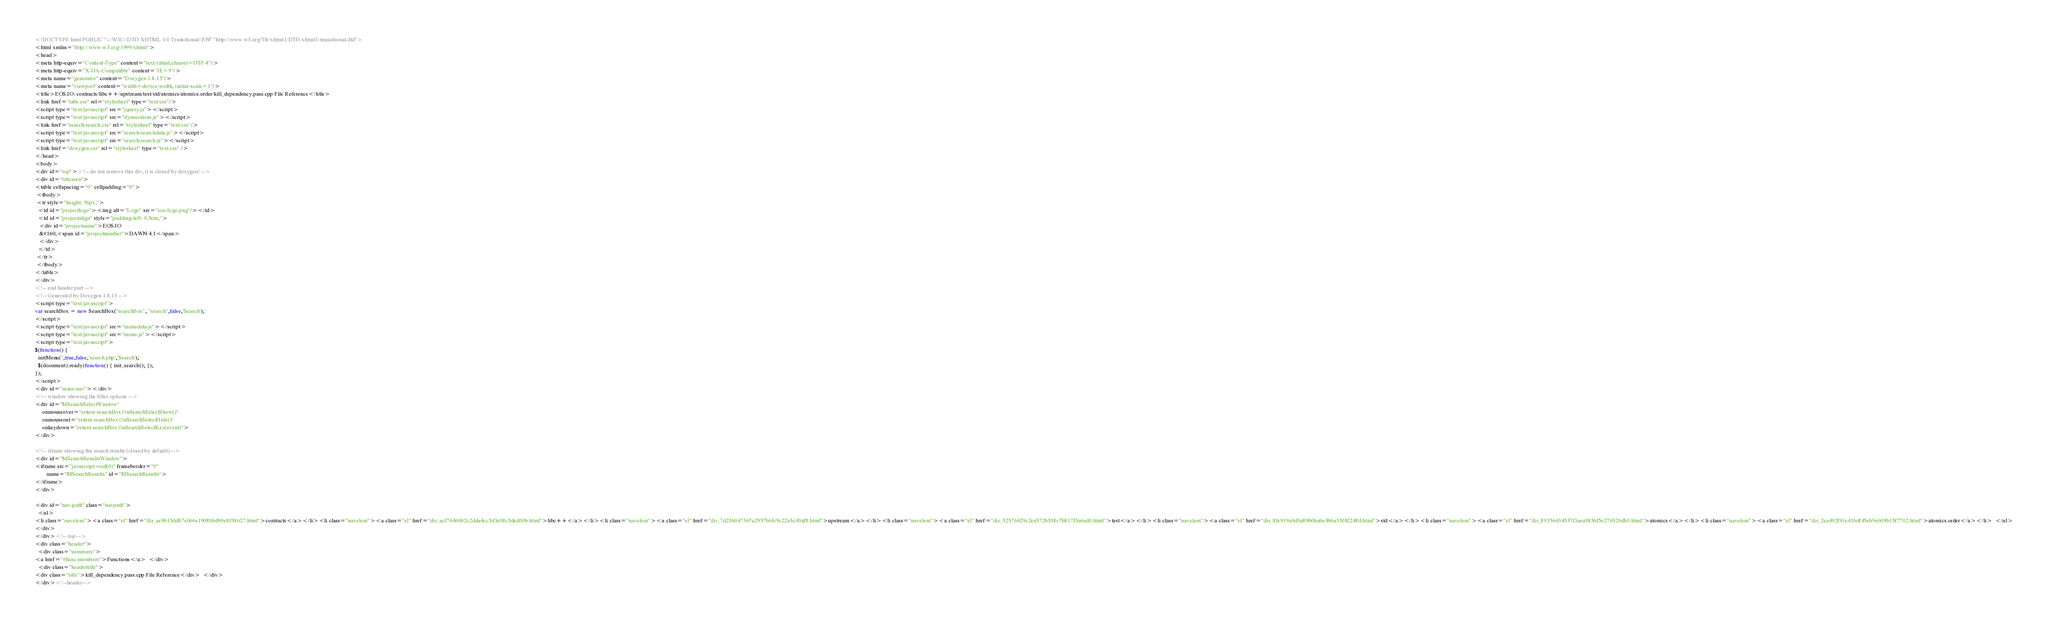Convert code to text. <code><loc_0><loc_0><loc_500><loc_500><_HTML_><!DOCTYPE html PUBLIC "-//W3C//DTD XHTML 1.0 Transitional//EN" "http://www.w3.org/TR/xhtml1/DTD/xhtml1-transitional.dtd">
<html xmlns="http://www.w3.org/1999/xhtml">
<head>
<meta http-equiv="Content-Type" content="text/xhtml;charset=UTF-8"/>
<meta http-equiv="X-UA-Compatible" content="IE=9"/>
<meta name="generator" content="Doxygen 1.8.13"/>
<meta name="viewport" content="width=device-width, initial-scale=1"/>
<title>EOS.IO: contracts/libc++/upstream/test/std/atomics/atomics.order/kill_dependency.pass.cpp File Reference</title>
<link href="tabs.css" rel="stylesheet" type="text/css"/>
<script type="text/javascript" src="jquery.js"></script>
<script type="text/javascript" src="dynsections.js"></script>
<link href="search/search.css" rel="stylesheet" type="text/css"/>
<script type="text/javascript" src="search/searchdata.js"></script>
<script type="text/javascript" src="search/search.js"></script>
<link href="doxygen.css" rel="stylesheet" type="text/css" />
</head>
<body>
<div id="top"><!-- do not remove this div, it is closed by doxygen! -->
<div id="titlearea">
<table cellspacing="0" cellpadding="0">
 <tbody>
 <tr style="height: 56px;">
  <td id="projectlogo"><img alt="Logo" src="eos-logo.png"/></td>
  <td id="projectalign" style="padding-left: 0.5em;">
   <div id="projectname">EOS.IO
   &#160;<span id="projectnumber">DAWN 4.1</span>
   </div>
  </td>
 </tr>
 </tbody>
</table>
</div>
<!-- end header part -->
<!-- Generated by Doxygen 1.8.13 -->
<script type="text/javascript">
var searchBox = new SearchBox("searchBox", "search",false,'Search');
</script>
<script type="text/javascript" src="menudata.js"></script>
<script type="text/javascript" src="menu.js"></script>
<script type="text/javascript">
$(function() {
  initMenu('',true,false,'search.php','Search');
  $(document).ready(function() { init_search(); });
});
</script>
<div id="main-nav"></div>
<!-- window showing the filter options -->
<div id="MSearchSelectWindow"
     onmouseover="return searchBox.OnSearchSelectShow()"
     onmouseout="return searchBox.OnSearchSelectHide()"
     onkeydown="return searchBox.OnSearchSelectKey(event)">
</div>

<!-- iframe showing the search results (closed by default) -->
<div id="MSearchResultsWindow">
<iframe src="javascript:void(0)" frameborder="0" 
        name="MSearchResults" id="MSearchResults">
</iframe>
</div>

<div id="nav-path" class="navpath">
  <ul>
<li class="navelem"><a class="el" href="dir_ae9b15dd87e066e1908bbd90e8f38627.html">contracts</a></li><li class="navelem"><a class="el" href="dir_acf7646062c2dda4cc5d3e08c5ded00b.html">libc++</a></li><li class="navelem"><a class="el" href="dir_7d236047367a2957b6fc9c22a3c49af8.html">upstream</a></li><li class="navelem"><a class="el" href="dir_52576429c2ea572b538c7b817f3a6ed0.html">test</a></li><li class="navelem"><a class="el" href="dir_8fe919a9d5a89b0babe3bba35f42248d.html">std</a></li><li class="navelem"><a class="el" href="dir_89156434537f3aea9856f5e276526db3.html">atomics</a></li><li class="navelem"><a class="el" href="dir_2ea492f91e41bdf45eb9e609b15f7702.html">atomics.order</a></li>  </ul>
</div>
</div><!-- top -->
<div class="header">
  <div class="summary">
<a href="#func-members">Functions</a>  </div>
  <div class="headertitle">
<div class="title">kill_dependency.pass.cpp File Reference</div>  </div>
</div><!--header--></code> 